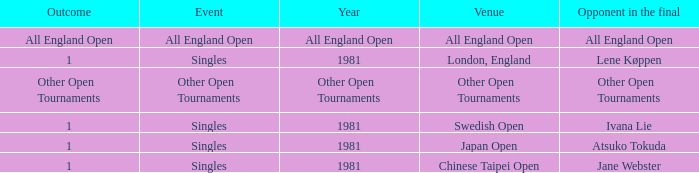Help me parse the entirety of this table. {'header': ['Outcome', 'Event', 'Year', 'Venue', 'Opponent in the final'], 'rows': [['All England Open', 'All England Open', 'All England Open', 'All England Open', 'All England Open'], ['1', 'Singles', '1981', 'London, England', 'Lene Køppen'], ['Other Open Tournaments', 'Other Open Tournaments', 'Other Open Tournaments', 'Other Open Tournaments', 'Other Open Tournaments'], ['1', 'Singles', '1981', 'Swedish Open', 'Ivana Lie'], ['1', 'Singles', '1981', 'Japan Open', 'Atsuko Tokuda'], ['1', 'Singles', '1981', 'Chinese Taipei Open', 'Jane Webster']]} What is the result of the singles event in london, england? 1.0. 